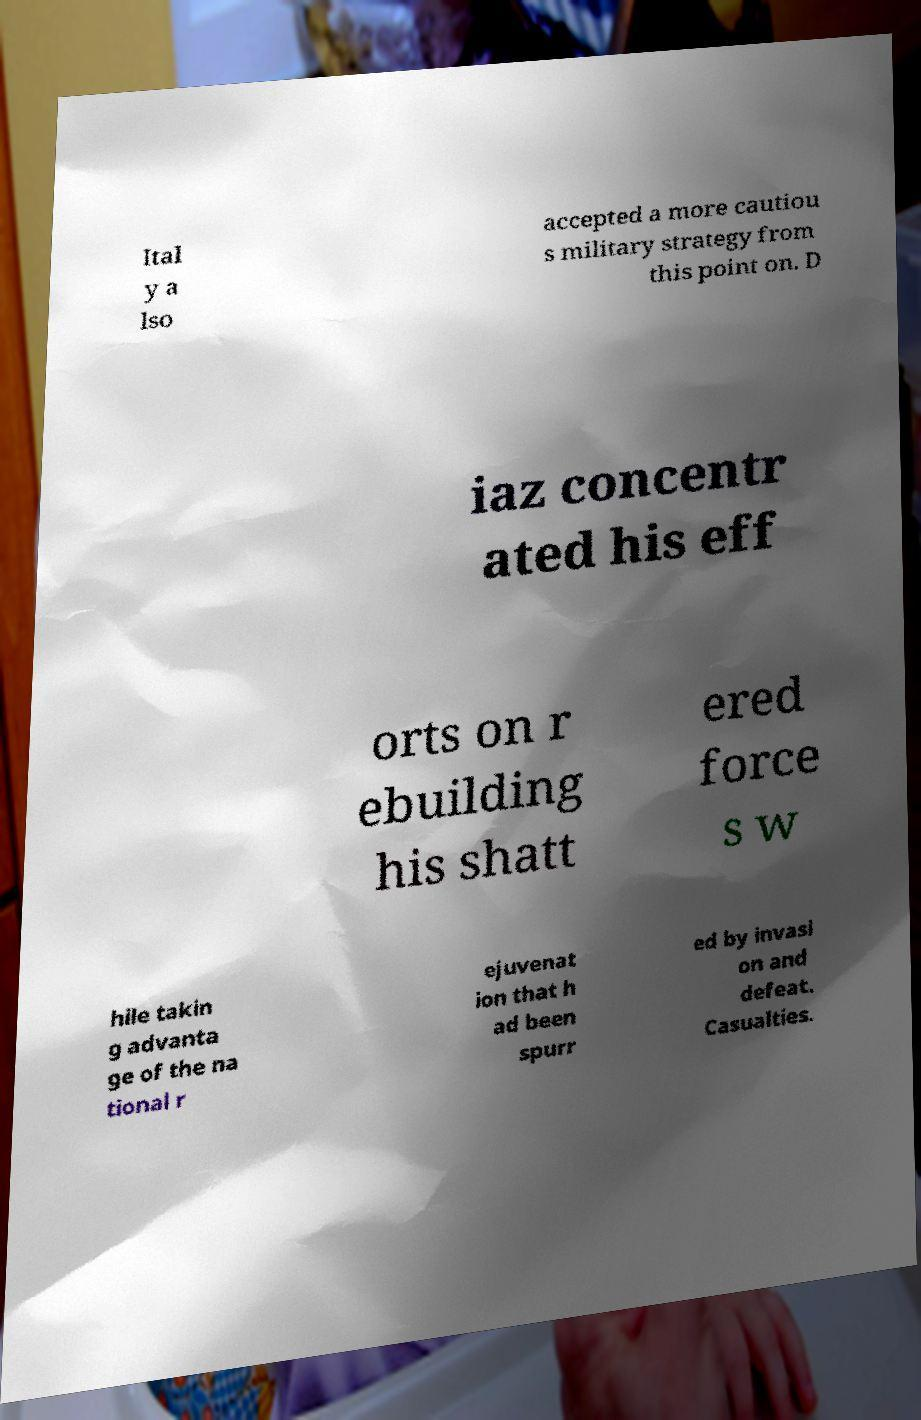Could you extract and type out the text from this image? Ital y a lso accepted a more cautiou s military strategy from this point on. D iaz concentr ated his eff orts on r ebuilding his shatt ered force s w hile takin g advanta ge of the na tional r ejuvenat ion that h ad been spurr ed by invasi on and defeat. Casualties. 